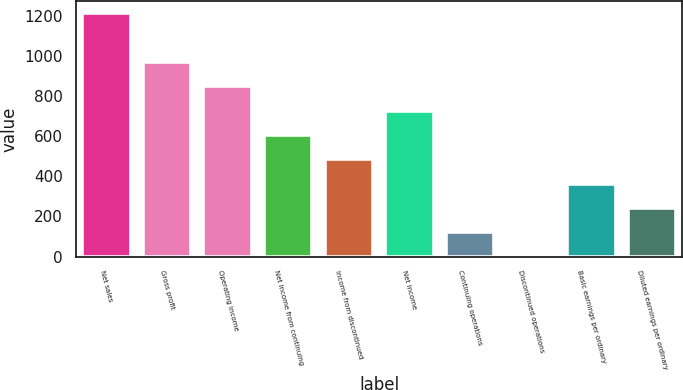Convert chart to OTSL. <chart><loc_0><loc_0><loc_500><loc_500><bar_chart><fcel>Net sales<fcel>Gross profit<fcel>Operating income<fcel>Net income from continuing<fcel>Income from discontinued<fcel>Net income<fcel>Continuing operations<fcel>Discontinued operations<fcel>Basic earnings per ordinary<fcel>Diluted earnings per ordinary<nl><fcel>1210.7<fcel>968.61<fcel>847.55<fcel>605.43<fcel>484.37<fcel>726.49<fcel>121.19<fcel>0.13<fcel>363.31<fcel>242.25<nl></chart> 